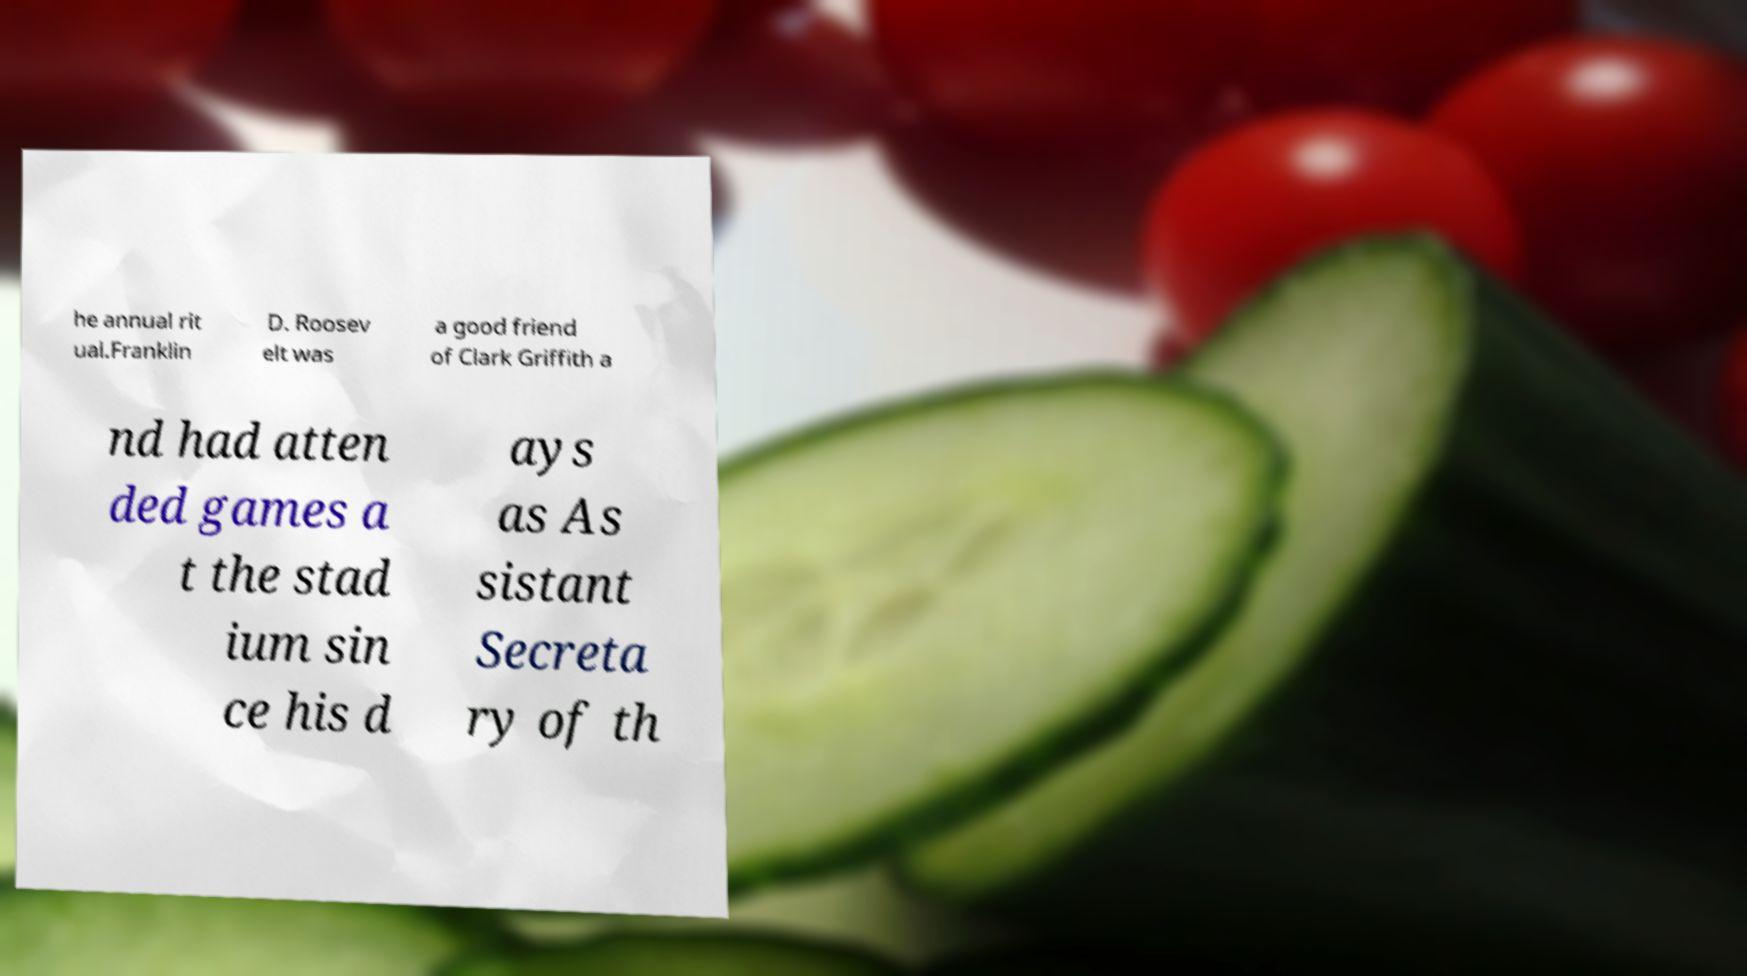What messages or text are displayed in this image? I need them in a readable, typed format. he annual rit ual.Franklin D. Roosev elt was a good friend of Clark Griffith a nd had atten ded games a t the stad ium sin ce his d ays as As sistant Secreta ry of th 